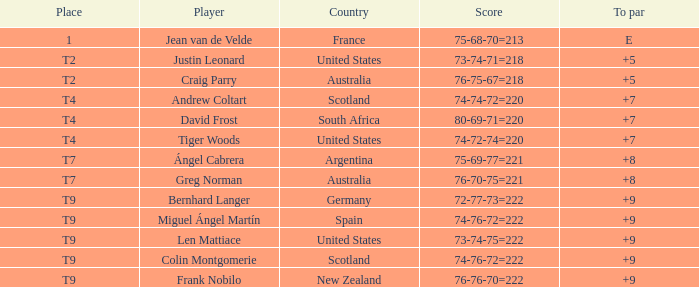Which player from Scotland has a To Par score of +7? Andrew Coltart. 